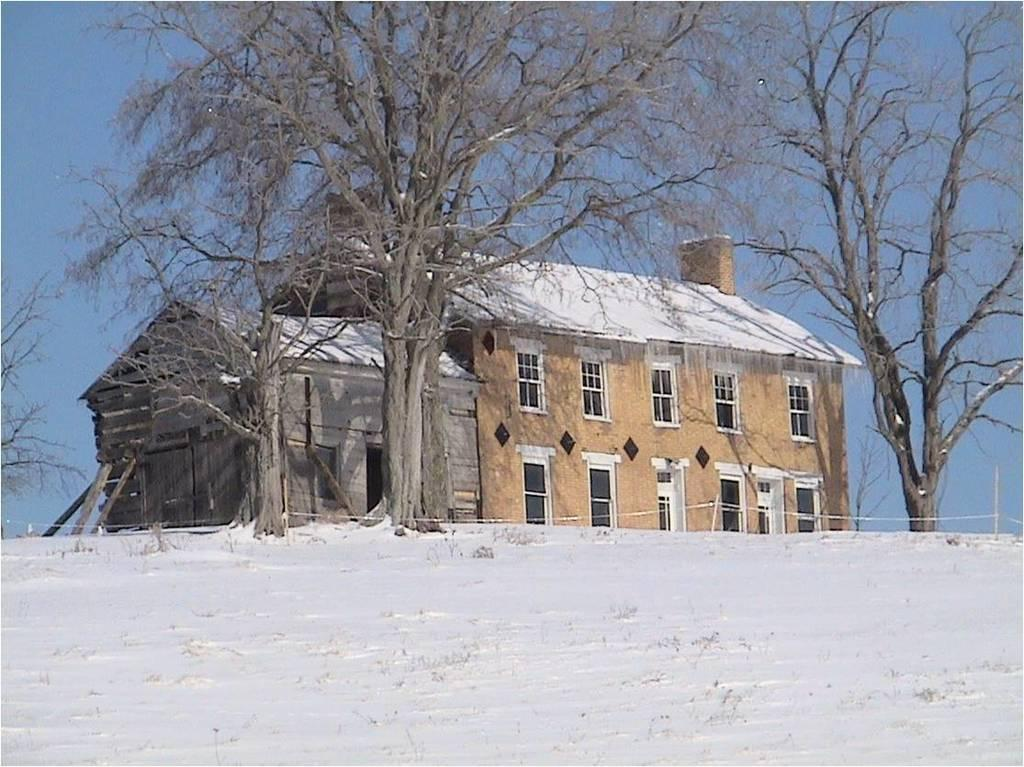What type of structures are visible in the image? There are houses with roofs and windows in the image. What natural elements can be seen in the image? There is a group of trees in the image. What man-made objects are present in the image? There are poles with wires and wooden poles in the image. What is visible in the sky in the image? The sky is visible in the image and appears cloudy. What type of account is being discussed in the image? There is no account being discussed in the image; it features houses, trees, and poles. Can you tell me how many dogs are visible in the image? There are no dogs present in the image. 